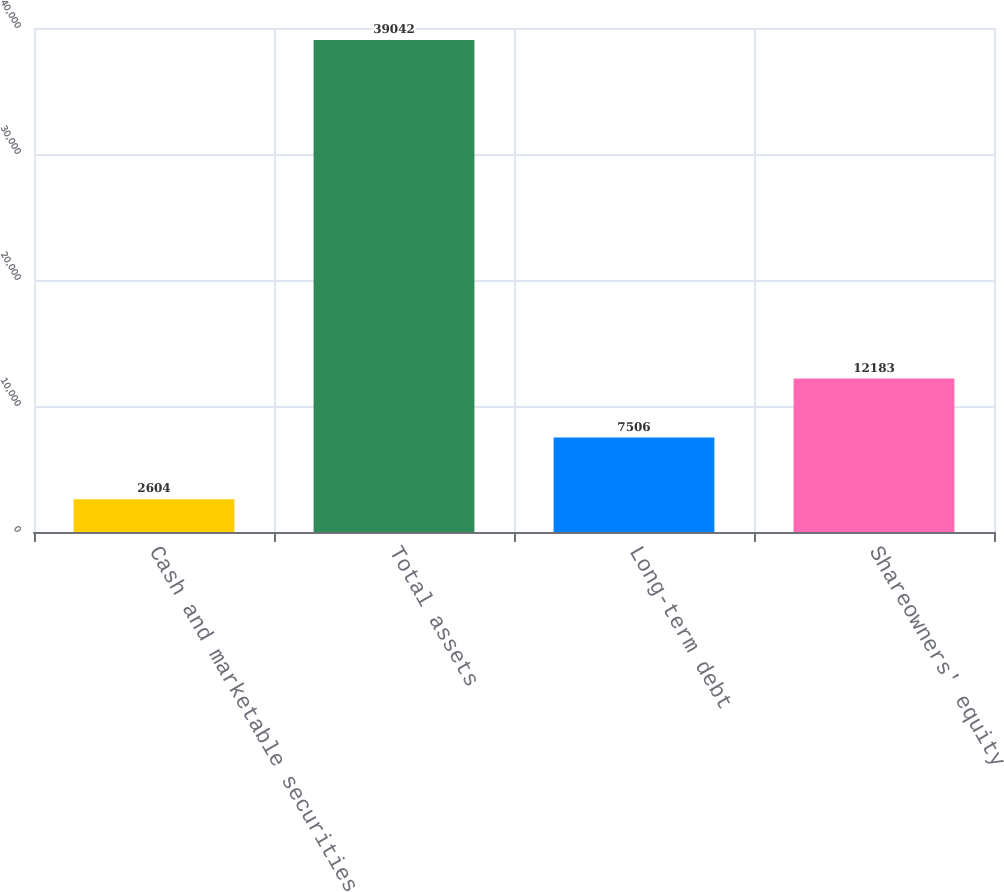Convert chart to OTSL. <chart><loc_0><loc_0><loc_500><loc_500><bar_chart><fcel>Cash and marketable securities<fcel>Total assets<fcel>Long-term debt<fcel>Shareowners' equity<nl><fcel>2604<fcel>39042<fcel>7506<fcel>12183<nl></chart> 